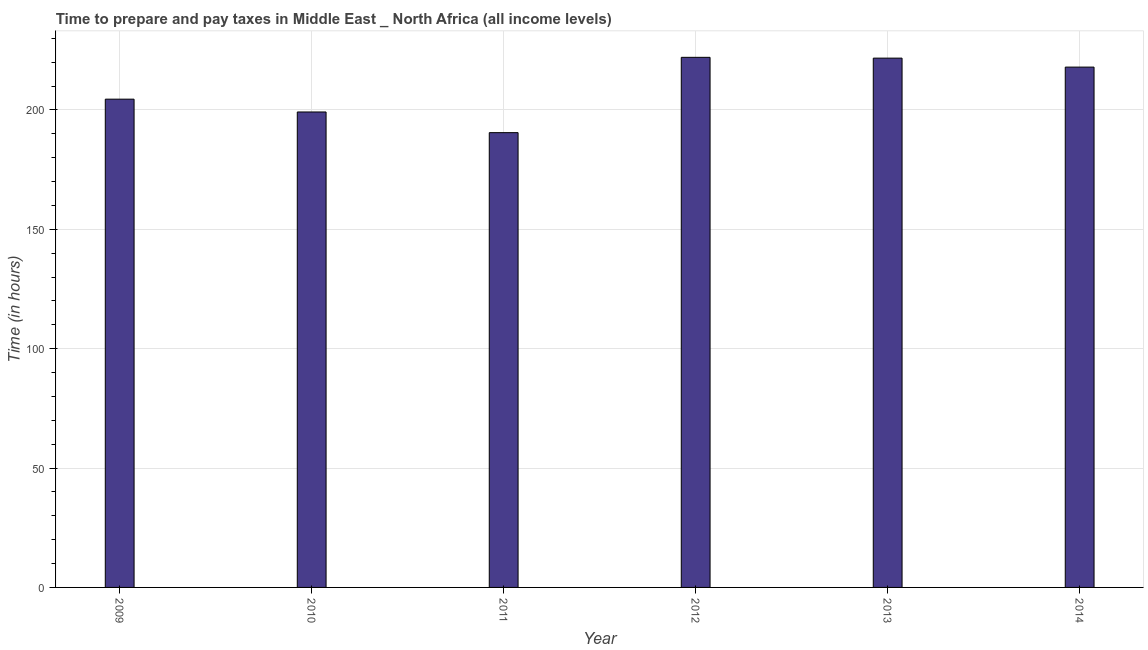Does the graph contain grids?
Your answer should be very brief. Yes. What is the title of the graph?
Ensure brevity in your answer.  Time to prepare and pay taxes in Middle East _ North Africa (all income levels). What is the label or title of the Y-axis?
Your answer should be very brief. Time (in hours). What is the time to prepare and pay taxes in 2013?
Offer a terse response. 221.71. Across all years, what is the maximum time to prepare and pay taxes?
Offer a very short reply. 222.05. Across all years, what is the minimum time to prepare and pay taxes?
Your answer should be compact. 190.5. In which year was the time to prepare and pay taxes maximum?
Your answer should be very brief. 2012. In which year was the time to prepare and pay taxes minimum?
Make the answer very short. 2011. What is the sum of the time to prepare and pay taxes?
Ensure brevity in your answer.  1255.9. What is the difference between the time to prepare and pay taxes in 2009 and 2012?
Give a very brief answer. -17.52. What is the average time to prepare and pay taxes per year?
Give a very brief answer. 209.32. What is the median time to prepare and pay taxes?
Ensure brevity in your answer.  211.24. In how many years, is the time to prepare and pay taxes greater than 160 hours?
Your response must be concise. 6. Do a majority of the years between 2013 and 2012 (inclusive) have time to prepare and pay taxes greater than 160 hours?
Your response must be concise. No. What is the ratio of the time to prepare and pay taxes in 2009 to that in 2011?
Your answer should be very brief. 1.07. Is the time to prepare and pay taxes in 2012 less than that in 2014?
Provide a succinct answer. No. Is the difference between the time to prepare and pay taxes in 2012 and 2014 greater than the difference between any two years?
Offer a terse response. No. What is the difference between the highest and the second highest time to prepare and pay taxes?
Give a very brief answer. 0.33. Is the sum of the time to prepare and pay taxes in 2009 and 2014 greater than the maximum time to prepare and pay taxes across all years?
Your response must be concise. Yes. What is the difference between the highest and the lowest time to prepare and pay taxes?
Offer a terse response. 31.55. How many years are there in the graph?
Your answer should be compact. 6. Are the values on the major ticks of Y-axis written in scientific E-notation?
Your answer should be very brief. No. What is the Time (in hours) in 2009?
Provide a succinct answer. 204.53. What is the Time (in hours) of 2010?
Make the answer very short. 199.16. What is the Time (in hours) of 2011?
Provide a succinct answer. 190.5. What is the Time (in hours) in 2012?
Your answer should be compact. 222.05. What is the Time (in hours) of 2013?
Provide a succinct answer. 221.71. What is the Time (in hours) in 2014?
Offer a terse response. 217.95. What is the difference between the Time (in hours) in 2009 and 2010?
Your answer should be very brief. 5.37. What is the difference between the Time (in hours) in 2009 and 2011?
Your answer should be very brief. 14.03. What is the difference between the Time (in hours) in 2009 and 2012?
Ensure brevity in your answer.  -17.52. What is the difference between the Time (in hours) in 2009 and 2013?
Ensure brevity in your answer.  -17.19. What is the difference between the Time (in hours) in 2009 and 2014?
Make the answer very short. -13.43. What is the difference between the Time (in hours) in 2010 and 2011?
Your answer should be very brief. 8.66. What is the difference between the Time (in hours) in 2010 and 2012?
Offer a very short reply. -22.89. What is the difference between the Time (in hours) in 2010 and 2013?
Offer a very short reply. -22.56. What is the difference between the Time (in hours) in 2010 and 2014?
Your answer should be very brief. -18.79. What is the difference between the Time (in hours) in 2011 and 2012?
Give a very brief answer. -31.55. What is the difference between the Time (in hours) in 2011 and 2013?
Give a very brief answer. -31.21. What is the difference between the Time (in hours) in 2011 and 2014?
Your answer should be very brief. -27.45. What is the difference between the Time (in hours) in 2012 and 2013?
Keep it short and to the point. 0.33. What is the difference between the Time (in hours) in 2012 and 2014?
Offer a very short reply. 4.1. What is the difference between the Time (in hours) in 2013 and 2014?
Your answer should be very brief. 3.76. What is the ratio of the Time (in hours) in 2009 to that in 2011?
Your answer should be compact. 1.07. What is the ratio of the Time (in hours) in 2009 to that in 2012?
Offer a terse response. 0.92. What is the ratio of the Time (in hours) in 2009 to that in 2013?
Ensure brevity in your answer.  0.92. What is the ratio of the Time (in hours) in 2009 to that in 2014?
Your response must be concise. 0.94. What is the ratio of the Time (in hours) in 2010 to that in 2011?
Ensure brevity in your answer.  1.04. What is the ratio of the Time (in hours) in 2010 to that in 2012?
Provide a succinct answer. 0.9. What is the ratio of the Time (in hours) in 2010 to that in 2013?
Your answer should be very brief. 0.9. What is the ratio of the Time (in hours) in 2010 to that in 2014?
Ensure brevity in your answer.  0.91. What is the ratio of the Time (in hours) in 2011 to that in 2012?
Your answer should be compact. 0.86. What is the ratio of the Time (in hours) in 2011 to that in 2013?
Make the answer very short. 0.86. What is the ratio of the Time (in hours) in 2011 to that in 2014?
Offer a terse response. 0.87. What is the ratio of the Time (in hours) in 2012 to that in 2014?
Provide a succinct answer. 1.02. 